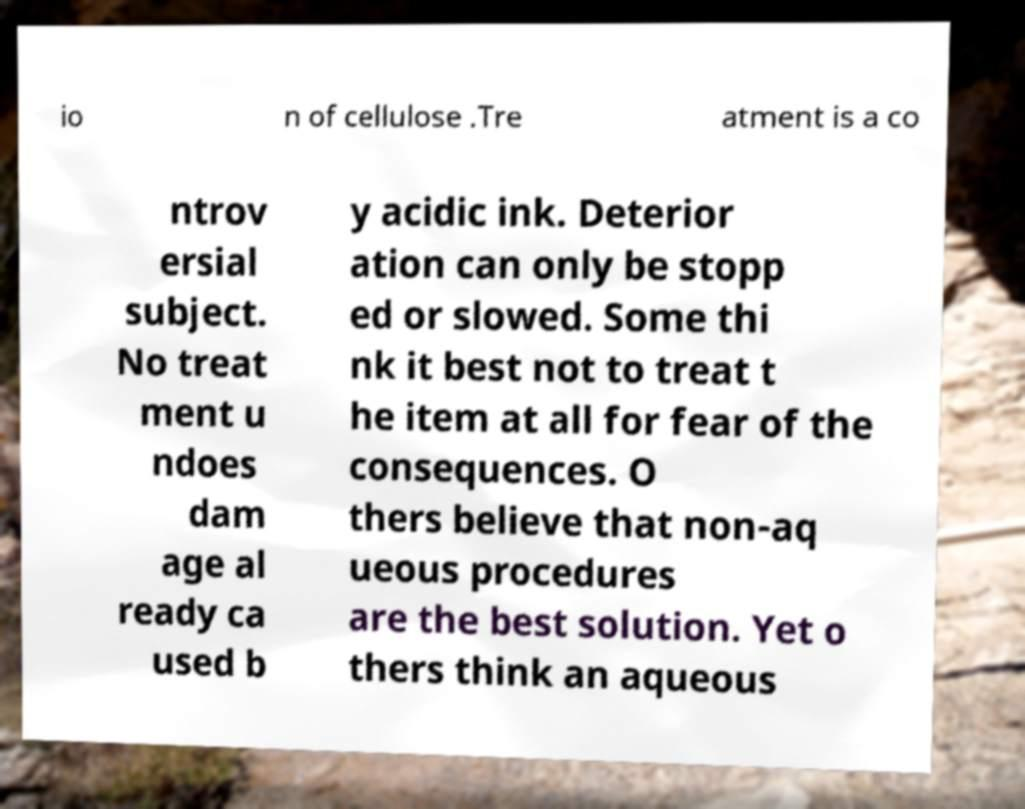Please identify and transcribe the text found in this image. io n of cellulose .Tre atment is a co ntrov ersial subject. No treat ment u ndoes dam age al ready ca used b y acidic ink. Deterior ation can only be stopp ed or slowed. Some thi nk it best not to treat t he item at all for fear of the consequences. O thers believe that non-aq ueous procedures are the best solution. Yet o thers think an aqueous 